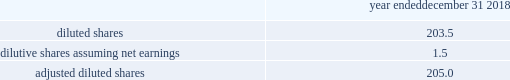Zimmer biomet holdings , inc .
2018 form 10-k annual report ( 8 ) we have incurred other various expenses from specific events or projects that we consider highly variable or have a significant impact to our operating results that we have excluded from our non-gaap financial measures .
This includes legal entity and operational restructuring as well as our costs of complying with our dpa with the u.s .
Government related to certain fcpa matters involving biomet and certain of its subsidiaries .
Under the dpa , which has a three-year term , we are subject to oversight by an independent compliance monitor , which monitorship commenced in july 2017 .
The excluded costs include the fees paid to the independent compliance monitor and to external legal counsel assisting in the matter .
( 9 ) represents the tax effects on the previously specified items .
The tax effect for the u.s .
Jurisdiction is calculated based on an effective rate considering federal and state taxes , as well as permanent items .
For jurisdictions outside the u.s. , the tax effect is calculated based upon the statutory rates where the items were incurred .
( 10 ) the 2016 period includes negative effects from finalizing the tax accounts for the biomet merger .
Under the applicable u.s .
Gaap rules , these measurement period adjustments are recognized on a prospective basis in the period of change .
( 11 ) the 2017 tax act resulted in a net favorable provisional adjustment due to the reduction of deferred tax liabilities for unremitted earnings and revaluation of deferred tax liabilities to a 21 percent rate , which was partially offset by provisional tax charges related to the toll charge provision of the 2017 tax act .
In 2018 , we finalized our estimates of the effects of the 2017 tax act based upon final guidance issued by u.s .
Tax authorities .
( 12 ) other certain tax adjustments in 2018 primarily related to changes in tax rates on deferred tax liabilities recorded on intangible assets recognized in acquisition-related accounting and adjustments from internal restructuring transactions that provide us access to offshore funds in a tax efficient manner .
In 2017 , other certain tax adjustments relate to tax benefits from lower tax rates unrelated to the impact of the 2017 tax act , net favorable resolutions of various tax matters and net favorable adjustments from internal restructuring transactions .
The 2016 adjustment primarily related to a favorable adjustment to certain deferred tax liabilities recognized as part of acquisition-related accounting and favorable resolution of certain tax matters with taxing authorities offset by internal restructuring transactions that provide us access to offshore funds in a tax efficient manner .
( 13 ) diluted share count used in adjusted diluted eps : year ended december 31 , 2018 .
Liquidity and capital resources cash flows provided by operating activities were $ 1747.4 million in 2018 compared to $ 1582.3 million and $ 1632.2 million in 2017 and 2016 , respectively .
The increase in operating cash flows in 2018 compared to 2017 was driven by additional cash flows from our sale of accounts receivable in certain countries , lower acquisition and integration expenses and lower quality remediation expenses , as well as certain significant payments made in the 2017 period .
In the 2017 period , we made payments related to the u.s .
Durom cup settlement program , and we paid $ 30.5 million in settlement payments to resolve previously-disclosed fcpa matters involving biomet and certain of its subsidiaries as discussed in note 19 to our consolidated financial statements included in item 8 of this report .
The decline in operating cash flows in 2017 compared to 2016 was driven by additional investments in inventory , additional expenses for quality remediation and the significant payments made in the 2017 period as discussed in the previous sentence .
These unfavorable items were partially offset by $ 174.0 million of incremental cash flows in 2017 from our sale of accounts receivable in certain countries .
Cash flows used in investing activities were $ 416.6 million in 2018 compared to $ 510.8 million and $ 1691.5 million in 2017 and 2016 , respectively .
Instrument and property , plant and equipment additions reflected ongoing investments in our product portfolio and optimization of our manufacturing and logistics network .
In 2018 , we entered into receive-fixed-rate , pay-fixed-rate cross-currency interest rate swaps .
Our investing cash flows reflect the net cash inflows from the fixed- rate interest rate receipts/payments , as well as the termination of certain of these swaps that were in a gain position in the year .
The 2016 period included cash outflows for the acquisition of ldr holding corporation ( 201cldr 201d ) and other business acquisitions .
Additionally , the 2016 period reflects the maturity of available-for-sale debt securities .
As these investments matured , we used the cash to pay off debt and have not reinvested in any additional debt securities .
Cash flows used in financing activities were $ 1302.2 million in 2018 .
Our primary use of available cash in 2018 was for debt repayment .
We received net proceeds of $ 749.5 million from the issuance of additional senior notes and borrowed $ 400.0 million from our multicurrency revolving facility to repay $ 1150.0 million of senior notes that became due on april 2 , 2018 .
We subsequently repaid the $ 400.0 million of multicurrency revolving facility borrowings .
Also in 2018 , we borrowed another $ 675.0 million under a new u.s .
Term loan c and used the cash proceeds along with cash generated from operations throughout the year to repay an aggregate of $ 835.0 million on u.s .
Term loan a , $ 450.0 million on u.s .
Term loan b , and we subsequently repaid $ 140.0 million on u.s .
Term loan c .
Overall , we had approximately $ 1150 million of net principal repayments on our senior notes and term loans in 2018 .
In 2017 , our primary use of available cash was also for debt repayment compared to 2016 when we were not able to repay as much debt due to financing requirements to complete the ldr and other business acquisitions .
Additionally in 2017 , we had net cash inflows of $ 103.5 million on factoring programs that had not been remitted to the third party .
In 2018 , we had net cash outflows related to these factoring programs as we remitted the $ 103.5 million and collected only $ 66.8 million which had not yet been remitted by the end of the year .
Since our factoring programs started at the end of 2016 , we did not have similar cash flows in that year .
In january 2019 , we borrowed an additional $ 200.0 million under u.s .
Term loan c and used those proceeds , along with cash on hand , to repay the remaining $ 225.0 million outstanding under u.s .
Term loan b .
In february , may , august and december 2018 , our board of directors declared cash dividends of $ 0.24 per share .
We expect to continue paying cash dividends on a quarterly basis ; however , future dividends are subject to approval of the board of directors and may be adjusted as business needs or market conditions change .
As further discussed in note 11 to our consolidated financial statements , our debt facilities restrict the payment of dividends in certain circumstances. .
What is the percent change in cash flows provided by operating activities between 2017 and 2016? 
Computations: ((1582.3 - 1632.2) / 1632.2)
Answer: -0.03057. 